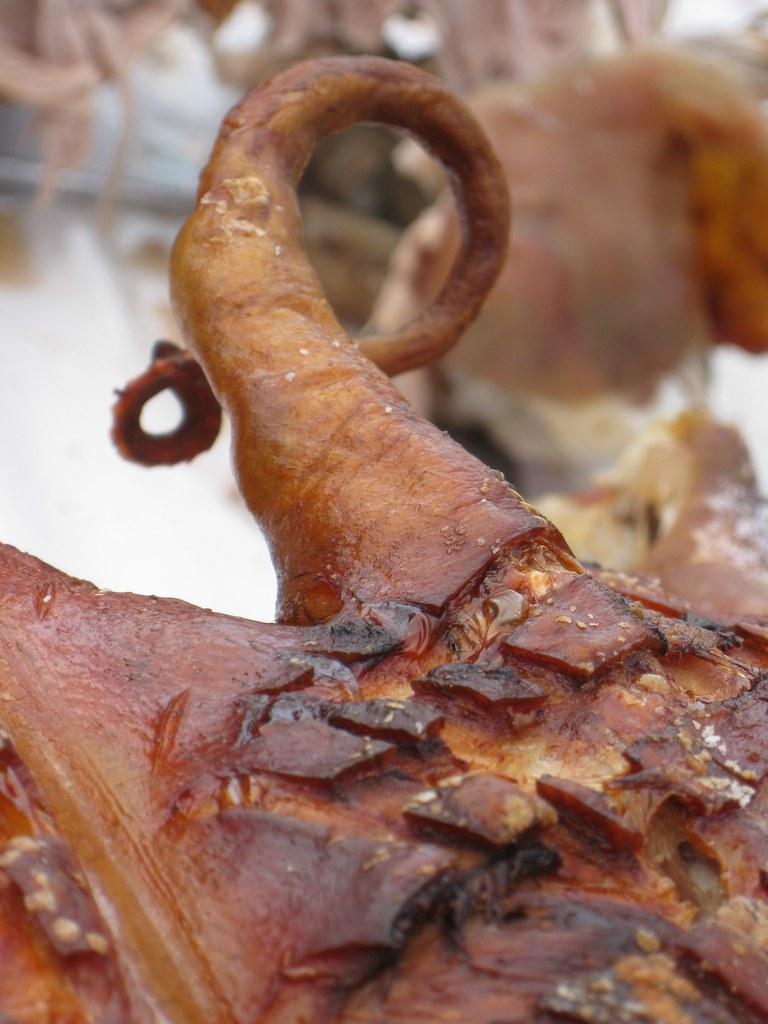Describe this image in one or two sentences. In this image I can see a food item which is orange, brown and black in color. In the background I can see few other items which are blurry. 